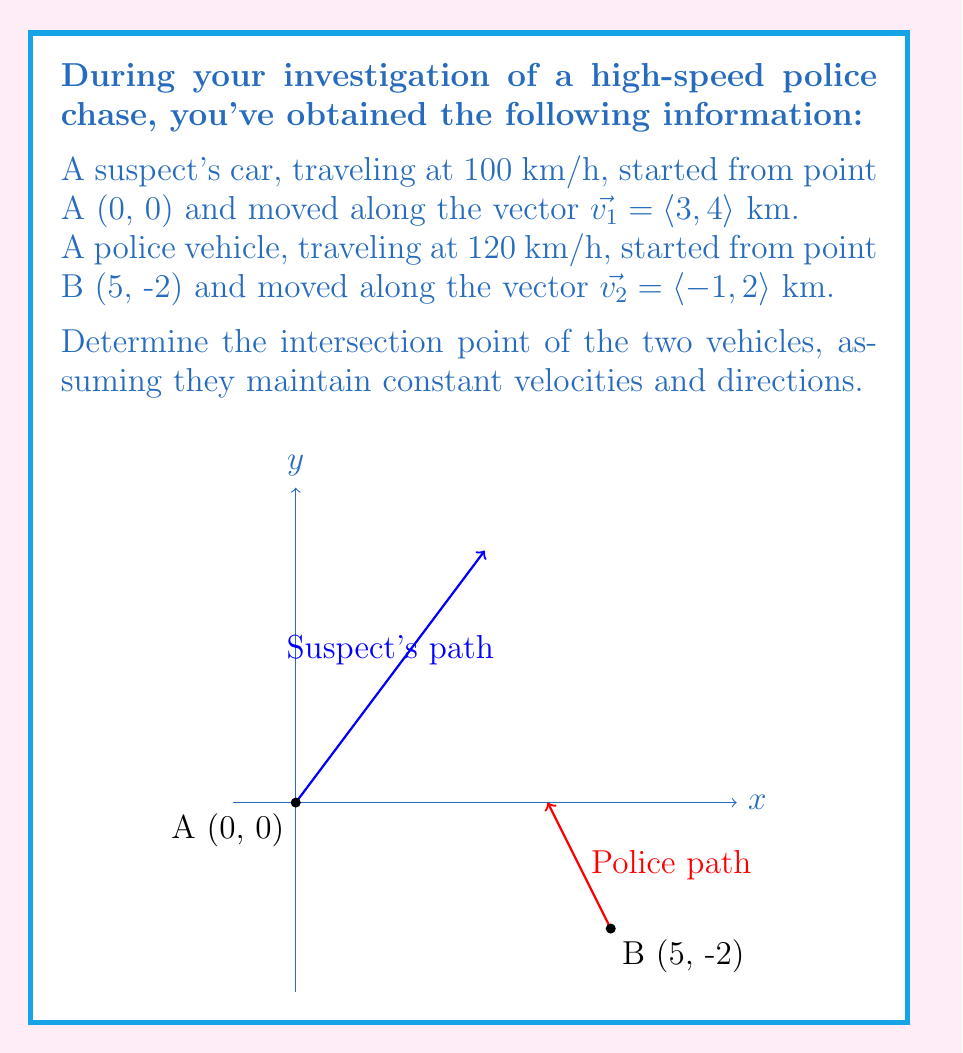Can you solve this math problem? Let's approach this step-by-step:

1) We need to find the parametric equations for both paths:

   Suspect's path: $\vec{r_1}(t) = \langle 0, 0 \rangle + t\langle 3, 4 \rangle = \langle 3t, 4t \rangle$
   Police path: $\vec{r_2}(s) = \langle 5, -2 \rangle + s\langle -1, 2 \rangle = \langle 5-s, -2+2s \rangle$

2) At the intersection point, these equations will be equal:

   $\langle 3t, 4t \rangle = \langle 5-s, -2+2s \rangle$

3) This gives us two equations:
   
   $3t = 5-s$
   $4t = -2+2s$

4) From the first equation: $s = 5-3t$

5) Substitute this into the second equation:
   
   $4t = -2+2(5-3t)$
   $4t = -2+10-6t$
   $10t = 8$
   $t = \frac{4}{5} = 0.8$

6) Now we can find $s$:
   
   $s = 5-3(\frac{4}{5}) = 5-2.4 = 2.6$

7) To find the intersection point, we can use either path equation. Let's use the suspect's:

   $\vec{r_1}(0.8) = \langle 3(0.8), 4(0.8) \rangle = \langle 2.4, 3.2 \rangle$

8) To verify, we can check the police path:
   
   $\vec{r_2}(2.6) = \langle 5-2.6, -2+2(2.6) \rangle = \langle 2.4, 3.2 \rangle$

Therefore, the intersection point is (2.4, 3.2).

9) We can also calculate the time to intersection:
   
   Suspect: $t_1 = \frac{0.8 \cdot 5}{100} = 0.04$ hours = 2.4 minutes
   Police: $t_2 = \frac{2.6 \cdot 5}{120} = 0.108$ hours = 6.5 minutes

The suspect reaches the intersection point first, which makes sense given their head start and the police's longer path.
Answer: (2.4, 3.2) 